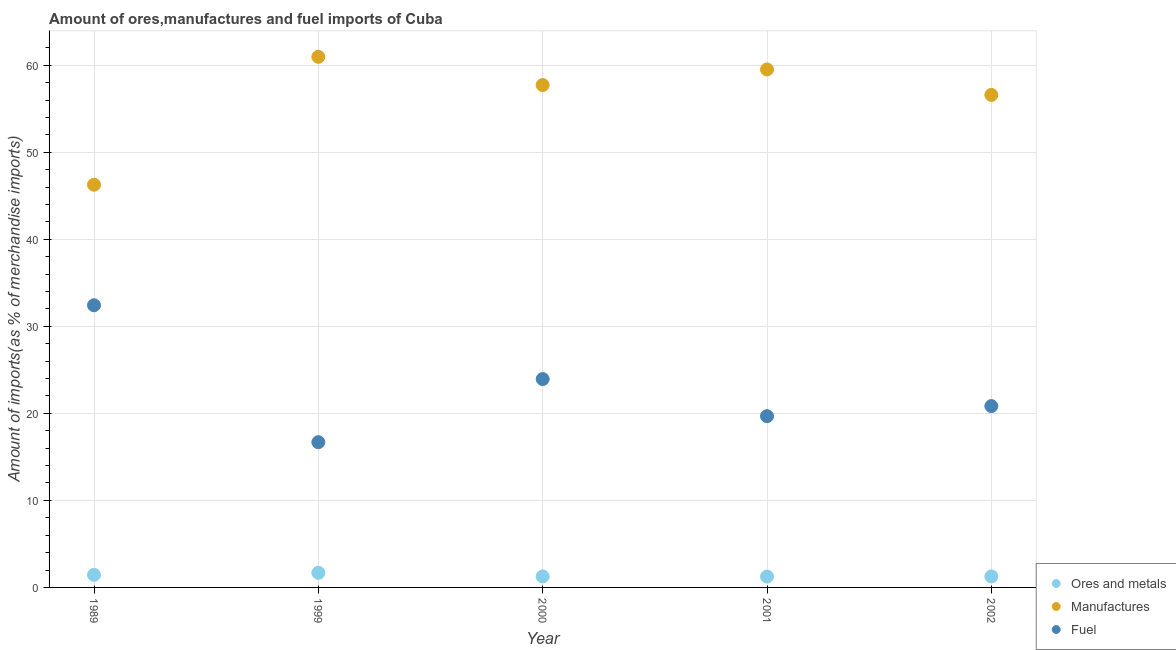How many different coloured dotlines are there?
Ensure brevity in your answer.  3. Is the number of dotlines equal to the number of legend labels?
Offer a terse response. Yes. What is the percentage of ores and metals imports in 1989?
Your answer should be very brief. 1.45. Across all years, what is the maximum percentage of ores and metals imports?
Make the answer very short. 1.68. Across all years, what is the minimum percentage of ores and metals imports?
Keep it short and to the point. 1.25. In which year was the percentage of manufactures imports maximum?
Keep it short and to the point. 1999. What is the total percentage of manufactures imports in the graph?
Offer a terse response. 281.06. What is the difference between the percentage of manufactures imports in 1989 and that in 2002?
Keep it short and to the point. -10.32. What is the difference between the percentage of ores and metals imports in 2002 and the percentage of fuel imports in 2000?
Your response must be concise. -22.68. What is the average percentage of manufactures imports per year?
Your answer should be compact. 56.21. In the year 2002, what is the difference between the percentage of ores and metals imports and percentage of fuel imports?
Provide a succinct answer. -19.57. In how many years, is the percentage of fuel imports greater than 46 %?
Make the answer very short. 0. What is the ratio of the percentage of manufactures imports in 1999 to that in 2001?
Offer a very short reply. 1.02. Is the percentage of ores and metals imports in 1989 less than that in 2001?
Your response must be concise. No. What is the difference between the highest and the second highest percentage of manufactures imports?
Provide a short and direct response. 1.45. What is the difference between the highest and the lowest percentage of fuel imports?
Offer a terse response. 15.73. In how many years, is the percentage of fuel imports greater than the average percentage of fuel imports taken over all years?
Provide a succinct answer. 2. Is it the case that in every year, the sum of the percentage of ores and metals imports and percentage of manufactures imports is greater than the percentage of fuel imports?
Keep it short and to the point. Yes. Is the percentage of manufactures imports strictly less than the percentage of ores and metals imports over the years?
Offer a very short reply. No. How many years are there in the graph?
Your answer should be very brief. 5. What is the difference between two consecutive major ticks on the Y-axis?
Give a very brief answer. 10. Where does the legend appear in the graph?
Offer a terse response. Bottom right. How are the legend labels stacked?
Ensure brevity in your answer.  Vertical. What is the title of the graph?
Keep it short and to the point. Amount of ores,manufactures and fuel imports of Cuba. What is the label or title of the Y-axis?
Give a very brief answer. Amount of imports(as % of merchandise imports). What is the Amount of imports(as % of merchandise imports) of Ores and metals in 1989?
Your answer should be compact. 1.45. What is the Amount of imports(as % of merchandise imports) in Manufactures in 1989?
Make the answer very short. 46.27. What is the Amount of imports(as % of merchandise imports) of Fuel in 1989?
Your answer should be very brief. 32.42. What is the Amount of imports(as % of merchandise imports) of Ores and metals in 1999?
Your response must be concise. 1.68. What is the Amount of imports(as % of merchandise imports) of Manufactures in 1999?
Your answer should be very brief. 60.97. What is the Amount of imports(as % of merchandise imports) of Fuel in 1999?
Keep it short and to the point. 16.69. What is the Amount of imports(as % of merchandise imports) in Ores and metals in 2000?
Your answer should be compact. 1.26. What is the Amount of imports(as % of merchandise imports) in Manufactures in 2000?
Your response must be concise. 57.72. What is the Amount of imports(as % of merchandise imports) in Fuel in 2000?
Offer a very short reply. 23.94. What is the Amount of imports(as % of merchandise imports) in Ores and metals in 2001?
Make the answer very short. 1.25. What is the Amount of imports(as % of merchandise imports) of Manufactures in 2001?
Provide a succinct answer. 59.51. What is the Amount of imports(as % of merchandise imports) in Fuel in 2001?
Your response must be concise. 19.68. What is the Amount of imports(as % of merchandise imports) in Ores and metals in 2002?
Keep it short and to the point. 1.26. What is the Amount of imports(as % of merchandise imports) in Manufactures in 2002?
Your answer should be compact. 56.59. What is the Amount of imports(as % of merchandise imports) in Fuel in 2002?
Make the answer very short. 20.84. Across all years, what is the maximum Amount of imports(as % of merchandise imports) in Ores and metals?
Provide a short and direct response. 1.68. Across all years, what is the maximum Amount of imports(as % of merchandise imports) in Manufactures?
Make the answer very short. 60.97. Across all years, what is the maximum Amount of imports(as % of merchandise imports) of Fuel?
Provide a short and direct response. 32.42. Across all years, what is the minimum Amount of imports(as % of merchandise imports) in Ores and metals?
Keep it short and to the point. 1.25. Across all years, what is the minimum Amount of imports(as % of merchandise imports) of Manufactures?
Ensure brevity in your answer.  46.27. Across all years, what is the minimum Amount of imports(as % of merchandise imports) in Fuel?
Your answer should be compact. 16.69. What is the total Amount of imports(as % of merchandise imports) of Ores and metals in the graph?
Ensure brevity in your answer.  6.9. What is the total Amount of imports(as % of merchandise imports) of Manufactures in the graph?
Offer a terse response. 281.06. What is the total Amount of imports(as % of merchandise imports) in Fuel in the graph?
Your answer should be very brief. 113.57. What is the difference between the Amount of imports(as % of merchandise imports) in Ores and metals in 1989 and that in 1999?
Offer a terse response. -0.23. What is the difference between the Amount of imports(as % of merchandise imports) in Manufactures in 1989 and that in 1999?
Ensure brevity in your answer.  -14.7. What is the difference between the Amount of imports(as % of merchandise imports) of Fuel in 1989 and that in 1999?
Ensure brevity in your answer.  15.73. What is the difference between the Amount of imports(as % of merchandise imports) of Ores and metals in 1989 and that in 2000?
Your response must be concise. 0.18. What is the difference between the Amount of imports(as % of merchandise imports) in Manufactures in 1989 and that in 2000?
Keep it short and to the point. -11.45. What is the difference between the Amount of imports(as % of merchandise imports) of Fuel in 1989 and that in 2000?
Your response must be concise. 8.48. What is the difference between the Amount of imports(as % of merchandise imports) of Ores and metals in 1989 and that in 2001?
Your answer should be very brief. 0.2. What is the difference between the Amount of imports(as % of merchandise imports) in Manufactures in 1989 and that in 2001?
Your answer should be very brief. -13.24. What is the difference between the Amount of imports(as % of merchandise imports) of Fuel in 1989 and that in 2001?
Give a very brief answer. 12.74. What is the difference between the Amount of imports(as % of merchandise imports) in Ores and metals in 1989 and that in 2002?
Your response must be concise. 0.18. What is the difference between the Amount of imports(as % of merchandise imports) of Manufactures in 1989 and that in 2002?
Provide a short and direct response. -10.32. What is the difference between the Amount of imports(as % of merchandise imports) in Fuel in 1989 and that in 2002?
Your answer should be very brief. 11.58. What is the difference between the Amount of imports(as % of merchandise imports) of Ores and metals in 1999 and that in 2000?
Keep it short and to the point. 0.42. What is the difference between the Amount of imports(as % of merchandise imports) of Manufactures in 1999 and that in 2000?
Provide a short and direct response. 3.24. What is the difference between the Amount of imports(as % of merchandise imports) in Fuel in 1999 and that in 2000?
Your answer should be compact. -7.25. What is the difference between the Amount of imports(as % of merchandise imports) in Ores and metals in 1999 and that in 2001?
Give a very brief answer. 0.43. What is the difference between the Amount of imports(as % of merchandise imports) in Manufactures in 1999 and that in 2001?
Offer a very short reply. 1.45. What is the difference between the Amount of imports(as % of merchandise imports) of Fuel in 1999 and that in 2001?
Your response must be concise. -2.99. What is the difference between the Amount of imports(as % of merchandise imports) in Ores and metals in 1999 and that in 2002?
Give a very brief answer. 0.42. What is the difference between the Amount of imports(as % of merchandise imports) of Manufactures in 1999 and that in 2002?
Offer a terse response. 4.38. What is the difference between the Amount of imports(as % of merchandise imports) in Fuel in 1999 and that in 2002?
Keep it short and to the point. -4.15. What is the difference between the Amount of imports(as % of merchandise imports) in Ores and metals in 2000 and that in 2001?
Make the answer very short. 0.01. What is the difference between the Amount of imports(as % of merchandise imports) in Manufactures in 2000 and that in 2001?
Offer a terse response. -1.79. What is the difference between the Amount of imports(as % of merchandise imports) of Fuel in 2000 and that in 2001?
Your answer should be very brief. 4.26. What is the difference between the Amount of imports(as % of merchandise imports) in Manufactures in 2000 and that in 2002?
Provide a short and direct response. 1.14. What is the difference between the Amount of imports(as % of merchandise imports) in Fuel in 2000 and that in 2002?
Your answer should be compact. 3.11. What is the difference between the Amount of imports(as % of merchandise imports) of Ores and metals in 2001 and that in 2002?
Your response must be concise. -0.01. What is the difference between the Amount of imports(as % of merchandise imports) in Manufactures in 2001 and that in 2002?
Provide a succinct answer. 2.93. What is the difference between the Amount of imports(as % of merchandise imports) of Fuel in 2001 and that in 2002?
Offer a very short reply. -1.16. What is the difference between the Amount of imports(as % of merchandise imports) in Ores and metals in 1989 and the Amount of imports(as % of merchandise imports) in Manufactures in 1999?
Give a very brief answer. -59.52. What is the difference between the Amount of imports(as % of merchandise imports) in Ores and metals in 1989 and the Amount of imports(as % of merchandise imports) in Fuel in 1999?
Ensure brevity in your answer.  -15.24. What is the difference between the Amount of imports(as % of merchandise imports) of Manufactures in 1989 and the Amount of imports(as % of merchandise imports) of Fuel in 1999?
Ensure brevity in your answer.  29.58. What is the difference between the Amount of imports(as % of merchandise imports) in Ores and metals in 1989 and the Amount of imports(as % of merchandise imports) in Manufactures in 2000?
Offer a terse response. -56.28. What is the difference between the Amount of imports(as % of merchandise imports) of Ores and metals in 1989 and the Amount of imports(as % of merchandise imports) of Fuel in 2000?
Provide a short and direct response. -22.5. What is the difference between the Amount of imports(as % of merchandise imports) of Manufactures in 1989 and the Amount of imports(as % of merchandise imports) of Fuel in 2000?
Offer a terse response. 22.33. What is the difference between the Amount of imports(as % of merchandise imports) of Ores and metals in 1989 and the Amount of imports(as % of merchandise imports) of Manufactures in 2001?
Your response must be concise. -58.07. What is the difference between the Amount of imports(as % of merchandise imports) in Ores and metals in 1989 and the Amount of imports(as % of merchandise imports) in Fuel in 2001?
Give a very brief answer. -18.23. What is the difference between the Amount of imports(as % of merchandise imports) of Manufactures in 1989 and the Amount of imports(as % of merchandise imports) of Fuel in 2001?
Offer a very short reply. 26.59. What is the difference between the Amount of imports(as % of merchandise imports) in Ores and metals in 1989 and the Amount of imports(as % of merchandise imports) in Manufactures in 2002?
Your answer should be very brief. -55.14. What is the difference between the Amount of imports(as % of merchandise imports) in Ores and metals in 1989 and the Amount of imports(as % of merchandise imports) in Fuel in 2002?
Provide a succinct answer. -19.39. What is the difference between the Amount of imports(as % of merchandise imports) in Manufactures in 1989 and the Amount of imports(as % of merchandise imports) in Fuel in 2002?
Keep it short and to the point. 25.43. What is the difference between the Amount of imports(as % of merchandise imports) in Ores and metals in 1999 and the Amount of imports(as % of merchandise imports) in Manufactures in 2000?
Your answer should be compact. -56.05. What is the difference between the Amount of imports(as % of merchandise imports) in Ores and metals in 1999 and the Amount of imports(as % of merchandise imports) in Fuel in 2000?
Your answer should be compact. -22.26. What is the difference between the Amount of imports(as % of merchandise imports) in Manufactures in 1999 and the Amount of imports(as % of merchandise imports) in Fuel in 2000?
Offer a very short reply. 37.03. What is the difference between the Amount of imports(as % of merchandise imports) of Ores and metals in 1999 and the Amount of imports(as % of merchandise imports) of Manufactures in 2001?
Make the answer very short. -57.83. What is the difference between the Amount of imports(as % of merchandise imports) of Ores and metals in 1999 and the Amount of imports(as % of merchandise imports) of Fuel in 2001?
Ensure brevity in your answer.  -18. What is the difference between the Amount of imports(as % of merchandise imports) of Manufactures in 1999 and the Amount of imports(as % of merchandise imports) of Fuel in 2001?
Give a very brief answer. 41.29. What is the difference between the Amount of imports(as % of merchandise imports) in Ores and metals in 1999 and the Amount of imports(as % of merchandise imports) in Manufactures in 2002?
Your answer should be very brief. -54.91. What is the difference between the Amount of imports(as % of merchandise imports) of Ores and metals in 1999 and the Amount of imports(as % of merchandise imports) of Fuel in 2002?
Offer a very short reply. -19.16. What is the difference between the Amount of imports(as % of merchandise imports) of Manufactures in 1999 and the Amount of imports(as % of merchandise imports) of Fuel in 2002?
Offer a very short reply. 40.13. What is the difference between the Amount of imports(as % of merchandise imports) in Ores and metals in 2000 and the Amount of imports(as % of merchandise imports) in Manufactures in 2001?
Offer a terse response. -58.25. What is the difference between the Amount of imports(as % of merchandise imports) in Ores and metals in 2000 and the Amount of imports(as % of merchandise imports) in Fuel in 2001?
Give a very brief answer. -18.41. What is the difference between the Amount of imports(as % of merchandise imports) of Manufactures in 2000 and the Amount of imports(as % of merchandise imports) of Fuel in 2001?
Your answer should be very brief. 38.05. What is the difference between the Amount of imports(as % of merchandise imports) of Ores and metals in 2000 and the Amount of imports(as % of merchandise imports) of Manufactures in 2002?
Offer a terse response. -55.33. What is the difference between the Amount of imports(as % of merchandise imports) in Ores and metals in 2000 and the Amount of imports(as % of merchandise imports) in Fuel in 2002?
Ensure brevity in your answer.  -19.57. What is the difference between the Amount of imports(as % of merchandise imports) of Manufactures in 2000 and the Amount of imports(as % of merchandise imports) of Fuel in 2002?
Provide a short and direct response. 36.89. What is the difference between the Amount of imports(as % of merchandise imports) in Ores and metals in 2001 and the Amount of imports(as % of merchandise imports) in Manufactures in 2002?
Ensure brevity in your answer.  -55.34. What is the difference between the Amount of imports(as % of merchandise imports) of Ores and metals in 2001 and the Amount of imports(as % of merchandise imports) of Fuel in 2002?
Your answer should be compact. -19.59. What is the difference between the Amount of imports(as % of merchandise imports) in Manufactures in 2001 and the Amount of imports(as % of merchandise imports) in Fuel in 2002?
Provide a short and direct response. 38.68. What is the average Amount of imports(as % of merchandise imports) in Ores and metals per year?
Your response must be concise. 1.38. What is the average Amount of imports(as % of merchandise imports) in Manufactures per year?
Your answer should be compact. 56.21. What is the average Amount of imports(as % of merchandise imports) in Fuel per year?
Make the answer very short. 22.71. In the year 1989, what is the difference between the Amount of imports(as % of merchandise imports) of Ores and metals and Amount of imports(as % of merchandise imports) of Manufactures?
Your answer should be compact. -44.82. In the year 1989, what is the difference between the Amount of imports(as % of merchandise imports) in Ores and metals and Amount of imports(as % of merchandise imports) in Fuel?
Ensure brevity in your answer.  -30.97. In the year 1989, what is the difference between the Amount of imports(as % of merchandise imports) of Manufactures and Amount of imports(as % of merchandise imports) of Fuel?
Your response must be concise. 13.85. In the year 1999, what is the difference between the Amount of imports(as % of merchandise imports) in Ores and metals and Amount of imports(as % of merchandise imports) in Manufactures?
Provide a succinct answer. -59.29. In the year 1999, what is the difference between the Amount of imports(as % of merchandise imports) of Ores and metals and Amount of imports(as % of merchandise imports) of Fuel?
Offer a very short reply. -15.01. In the year 1999, what is the difference between the Amount of imports(as % of merchandise imports) in Manufactures and Amount of imports(as % of merchandise imports) in Fuel?
Provide a short and direct response. 44.28. In the year 2000, what is the difference between the Amount of imports(as % of merchandise imports) of Ores and metals and Amount of imports(as % of merchandise imports) of Manufactures?
Your response must be concise. -56.46. In the year 2000, what is the difference between the Amount of imports(as % of merchandise imports) in Ores and metals and Amount of imports(as % of merchandise imports) in Fuel?
Provide a short and direct response. -22.68. In the year 2000, what is the difference between the Amount of imports(as % of merchandise imports) of Manufactures and Amount of imports(as % of merchandise imports) of Fuel?
Your answer should be compact. 33.78. In the year 2001, what is the difference between the Amount of imports(as % of merchandise imports) of Ores and metals and Amount of imports(as % of merchandise imports) of Manufactures?
Make the answer very short. -58.27. In the year 2001, what is the difference between the Amount of imports(as % of merchandise imports) in Ores and metals and Amount of imports(as % of merchandise imports) in Fuel?
Provide a succinct answer. -18.43. In the year 2001, what is the difference between the Amount of imports(as % of merchandise imports) in Manufactures and Amount of imports(as % of merchandise imports) in Fuel?
Keep it short and to the point. 39.84. In the year 2002, what is the difference between the Amount of imports(as % of merchandise imports) of Ores and metals and Amount of imports(as % of merchandise imports) of Manufactures?
Provide a succinct answer. -55.33. In the year 2002, what is the difference between the Amount of imports(as % of merchandise imports) of Ores and metals and Amount of imports(as % of merchandise imports) of Fuel?
Provide a succinct answer. -19.57. In the year 2002, what is the difference between the Amount of imports(as % of merchandise imports) in Manufactures and Amount of imports(as % of merchandise imports) in Fuel?
Ensure brevity in your answer.  35.75. What is the ratio of the Amount of imports(as % of merchandise imports) in Ores and metals in 1989 to that in 1999?
Provide a succinct answer. 0.86. What is the ratio of the Amount of imports(as % of merchandise imports) of Manufactures in 1989 to that in 1999?
Provide a short and direct response. 0.76. What is the ratio of the Amount of imports(as % of merchandise imports) of Fuel in 1989 to that in 1999?
Offer a terse response. 1.94. What is the ratio of the Amount of imports(as % of merchandise imports) in Ores and metals in 1989 to that in 2000?
Offer a terse response. 1.14. What is the ratio of the Amount of imports(as % of merchandise imports) of Manufactures in 1989 to that in 2000?
Give a very brief answer. 0.8. What is the ratio of the Amount of imports(as % of merchandise imports) of Fuel in 1989 to that in 2000?
Your answer should be compact. 1.35. What is the ratio of the Amount of imports(as % of merchandise imports) of Ores and metals in 1989 to that in 2001?
Keep it short and to the point. 1.16. What is the ratio of the Amount of imports(as % of merchandise imports) in Manufactures in 1989 to that in 2001?
Provide a short and direct response. 0.78. What is the ratio of the Amount of imports(as % of merchandise imports) in Fuel in 1989 to that in 2001?
Offer a very short reply. 1.65. What is the ratio of the Amount of imports(as % of merchandise imports) in Ores and metals in 1989 to that in 2002?
Provide a succinct answer. 1.15. What is the ratio of the Amount of imports(as % of merchandise imports) in Manufactures in 1989 to that in 2002?
Make the answer very short. 0.82. What is the ratio of the Amount of imports(as % of merchandise imports) of Fuel in 1989 to that in 2002?
Make the answer very short. 1.56. What is the ratio of the Amount of imports(as % of merchandise imports) in Ores and metals in 1999 to that in 2000?
Give a very brief answer. 1.33. What is the ratio of the Amount of imports(as % of merchandise imports) in Manufactures in 1999 to that in 2000?
Provide a succinct answer. 1.06. What is the ratio of the Amount of imports(as % of merchandise imports) in Fuel in 1999 to that in 2000?
Offer a terse response. 0.7. What is the ratio of the Amount of imports(as % of merchandise imports) of Ores and metals in 1999 to that in 2001?
Offer a terse response. 1.35. What is the ratio of the Amount of imports(as % of merchandise imports) of Manufactures in 1999 to that in 2001?
Your answer should be compact. 1.02. What is the ratio of the Amount of imports(as % of merchandise imports) in Fuel in 1999 to that in 2001?
Your answer should be very brief. 0.85. What is the ratio of the Amount of imports(as % of merchandise imports) of Ores and metals in 1999 to that in 2002?
Your answer should be very brief. 1.33. What is the ratio of the Amount of imports(as % of merchandise imports) in Manufactures in 1999 to that in 2002?
Keep it short and to the point. 1.08. What is the ratio of the Amount of imports(as % of merchandise imports) of Fuel in 1999 to that in 2002?
Offer a terse response. 0.8. What is the ratio of the Amount of imports(as % of merchandise imports) in Ores and metals in 2000 to that in 2001?
Your answer should be very brief. 1.01. What is the ratio of the Amount of imports(as % of merchandise imports) in Manufactures in 2000 to that in 2001?
Provide a succinct answer. 0.97. What is the ratio of the Amount of imports(as % of merchandise imports) in Fuel in 2000 to that in 2001?
Make the answer very short. 1.22. What is the ratio of the Amount of imports(as % of merchandise imports) of Manufactures in 2000 to that in 2002?
Give a very brief answer. 1.02. What is the ratio of the Amount of imports(as % of merchandise imports) in Fuel in 2000 to that in 2002?
Provide a succinct answer. 1.15. What is the ratio of the Amount of imports(as % of merchandise imports) in Ores and metals in 2001 to that in 2002?
Provide a succinct answer. 0.99. What is the ratio of the Amount of imports(as % of merchandise imports) in Manufactures in 2001 to that in 2002?
Your answer should be compact. 1.05. What is the ratio of the Amount of imports(as % of merchandise imports) of Fuel in 2001 to that in 2002?
Keep it short and to the point. 0.94. What is the difference between the highest and the second highest Amount of imports(as % of merchandise imports) of Ores and metals?
Your response must be concise. 0.23. What is the difference between the highest and the second highest Amount of imports(as % of merchandise imports) in Manufactures?
Your response must be concise. 1.45. What is the difference between the highest and the second highest Amount of imports(as % of merchandise imports) in Fuel?
Your response must be concise. 8.48. What is the difference between the highest and the lowest Amount of imports(as % of merchandise imports) in Ores and metals?
Your answer should be very brief. 0.43. What is the difference between the highest and the lowest Amount of imports(as % of merchandise imports) in Manufactures?
Offer a terse response. 14.7. What is the difference between the highest and the lowest Amount of imports(as % of merchandise imports) of Fuel?
Provide a short and direct response. 15.73. 